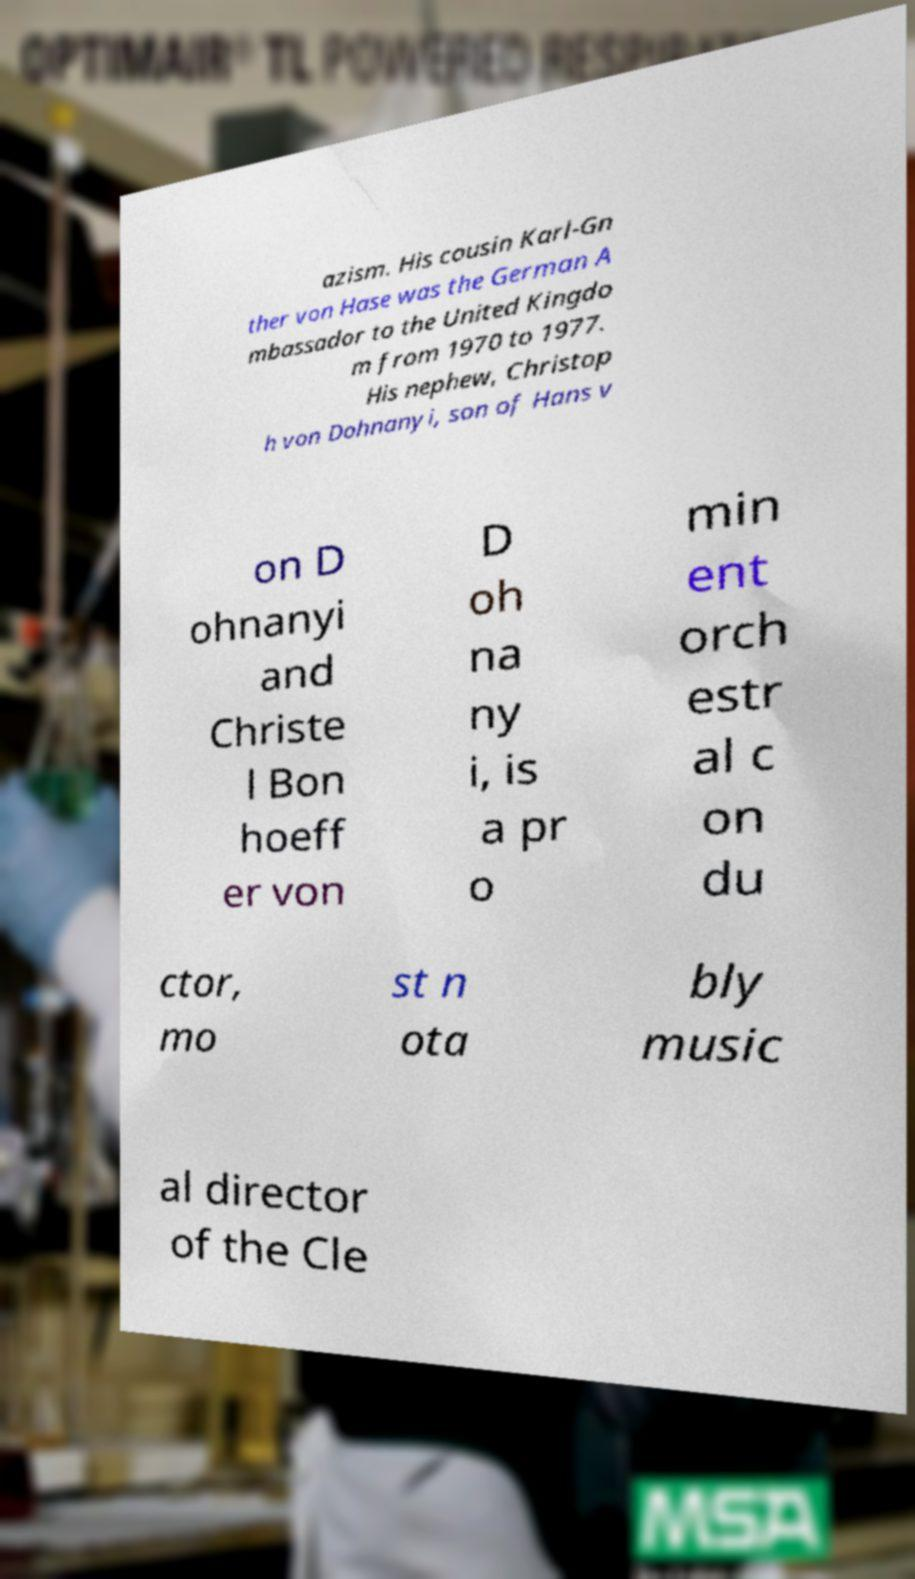There's text embedded in this image that I need extracted. Can you transcribe it verbatim? azism. His cousin Karl-Gn ther von Hase was the German A mbassador to the United Kingdo m from 1970 to 1977. His nephew, Christop h von Dohnanyi, son of Hans v on D ohnanyi and Christe l Bon hoeff er von D oh na ny i, is a pr o min ent orch estr al c on du ctor, mo st n ota bly music al director of the Cle 